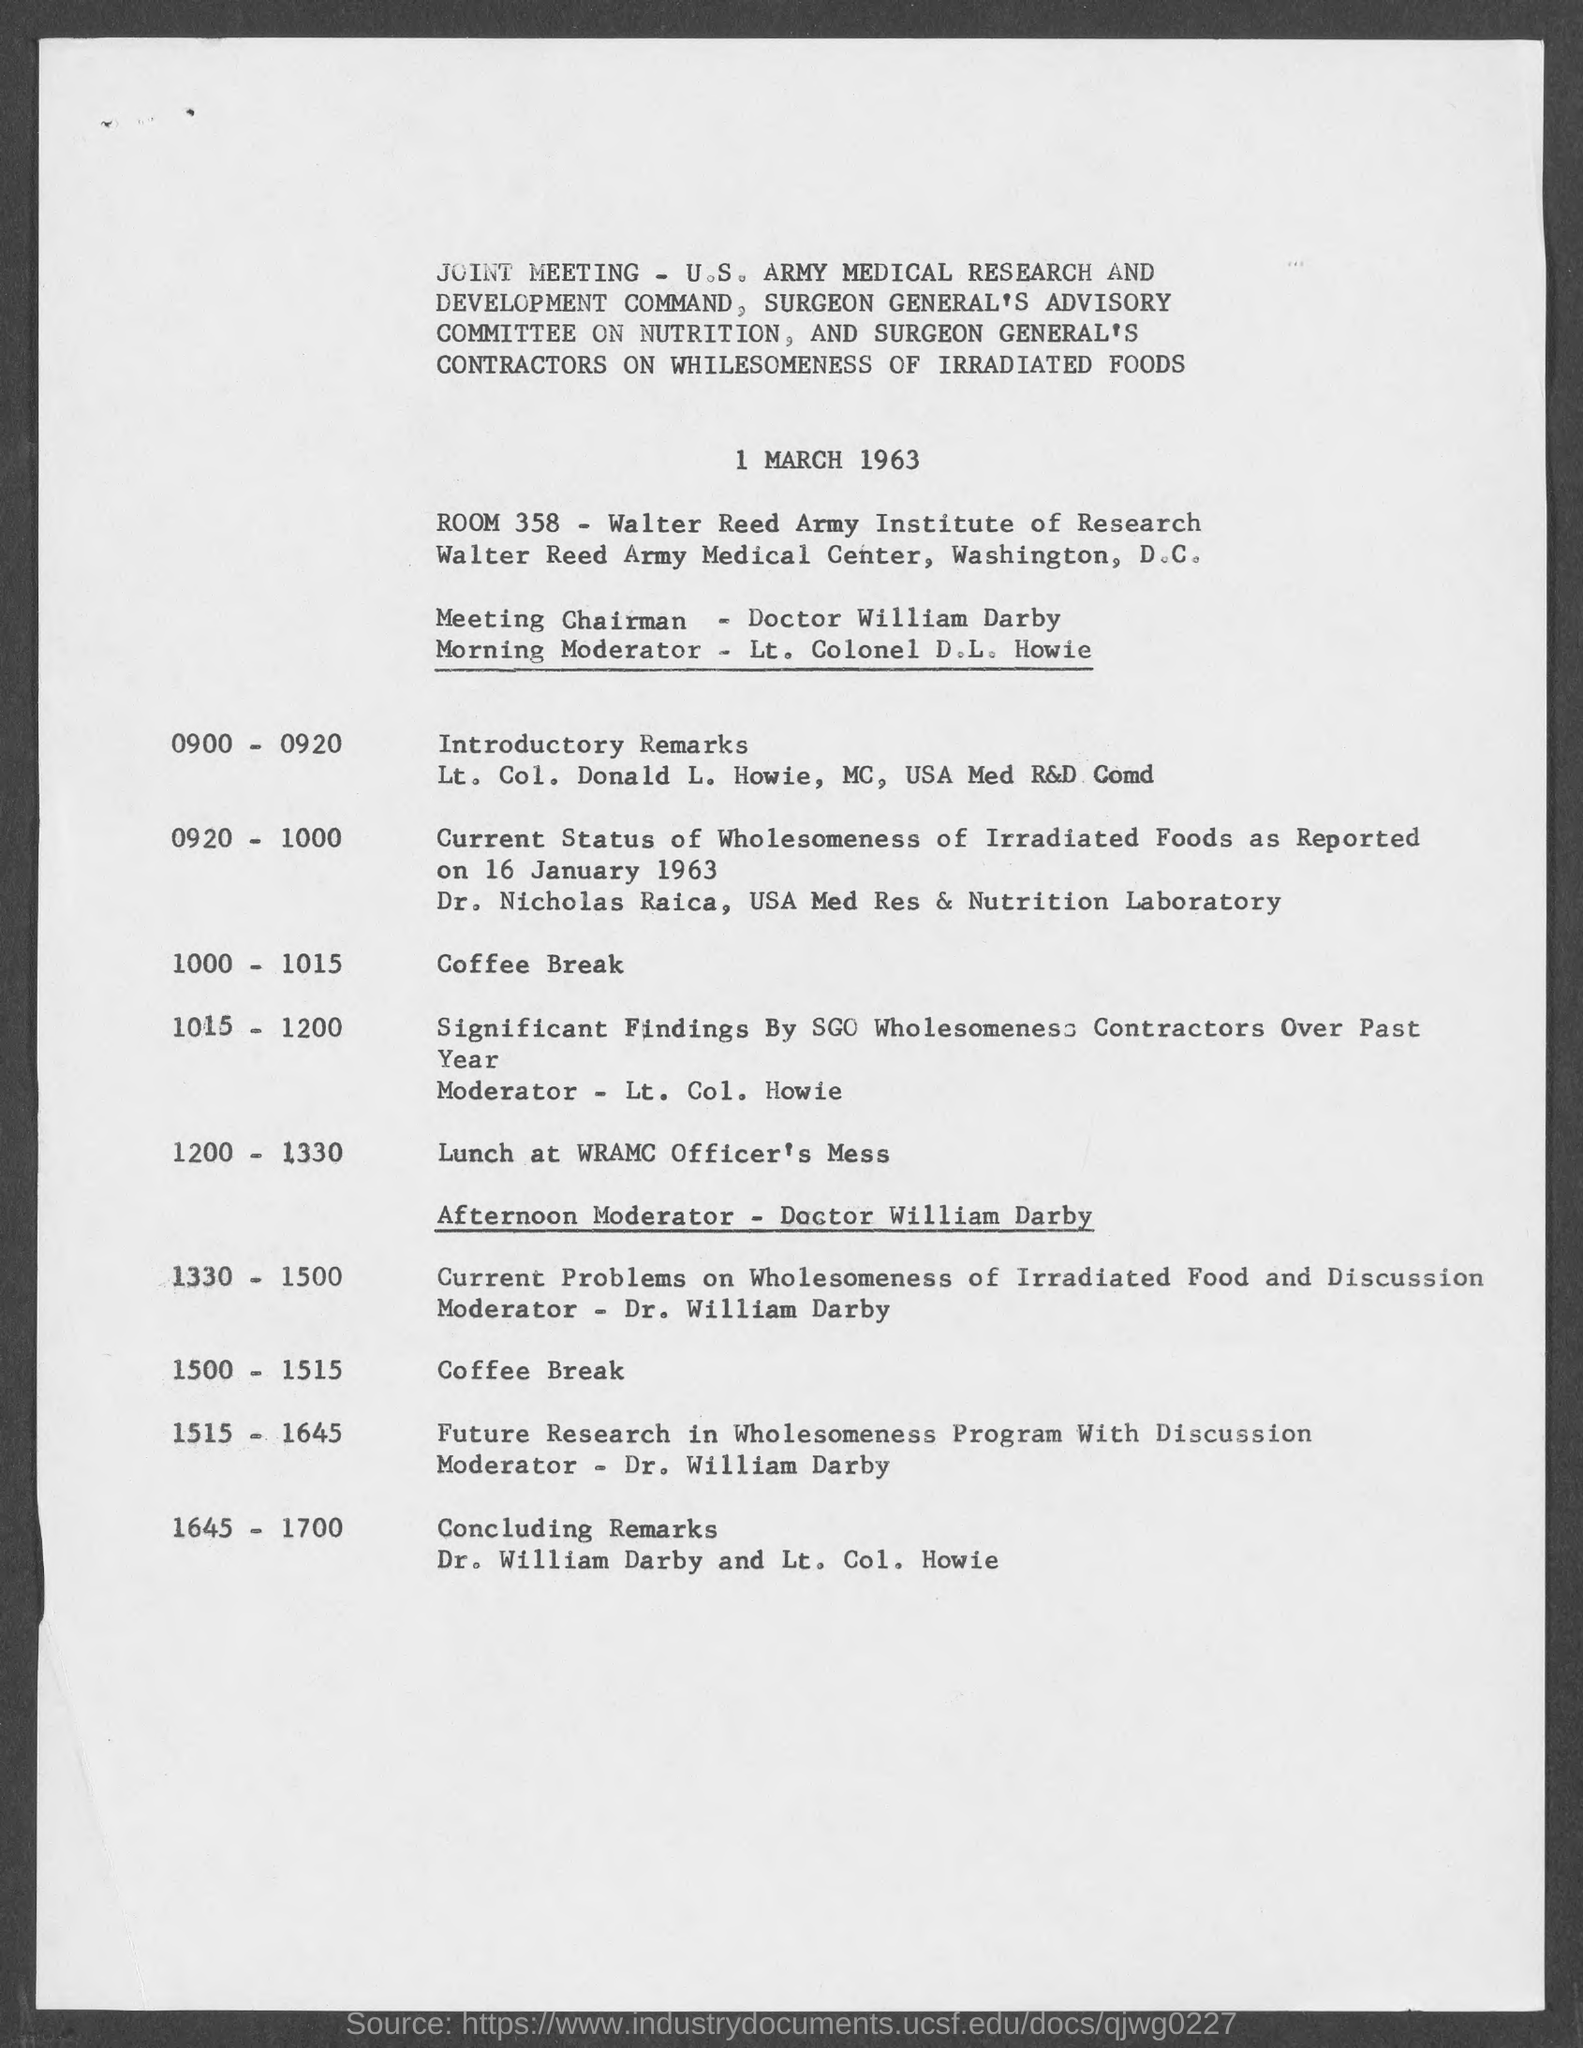List a handful of essential elements in this visual. The room number is 358. The joint meeting was held on March 1, 1963. The venue for lunch is the WRAMCO Officer's Mess. The morning moderator is Lieutenant Colonel D.L. Howie. It has been announced that Doctor William Darby will be the moderator for the afternoon session. 